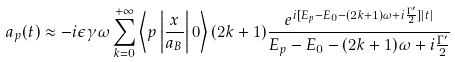Convert formula to latex. <formula><loc_0><loc_0><loc_500><loc_500>a _ { p } ( t ) \approx - i \epsilon \gamma \omega \sum _ { k = 0 } ^ { + \infty } \left \langle { p } \left | \frac { x } { a _ { B } } \right | 0 \right \rangle ( 2 k + 1 ) \frac { e ^ { i [ E _ { p } - E _ { 0 } - ( 2 k + 1 ) \omega + i \frac { \Gamma ^ { \prime } } { 2 } ] | t | } } { E _ { p } - E _ { 0 } - ( 2 k + 1 ) \omega + i \frac { \Gamma ^ { \prime } } { 2 } }</formula> 